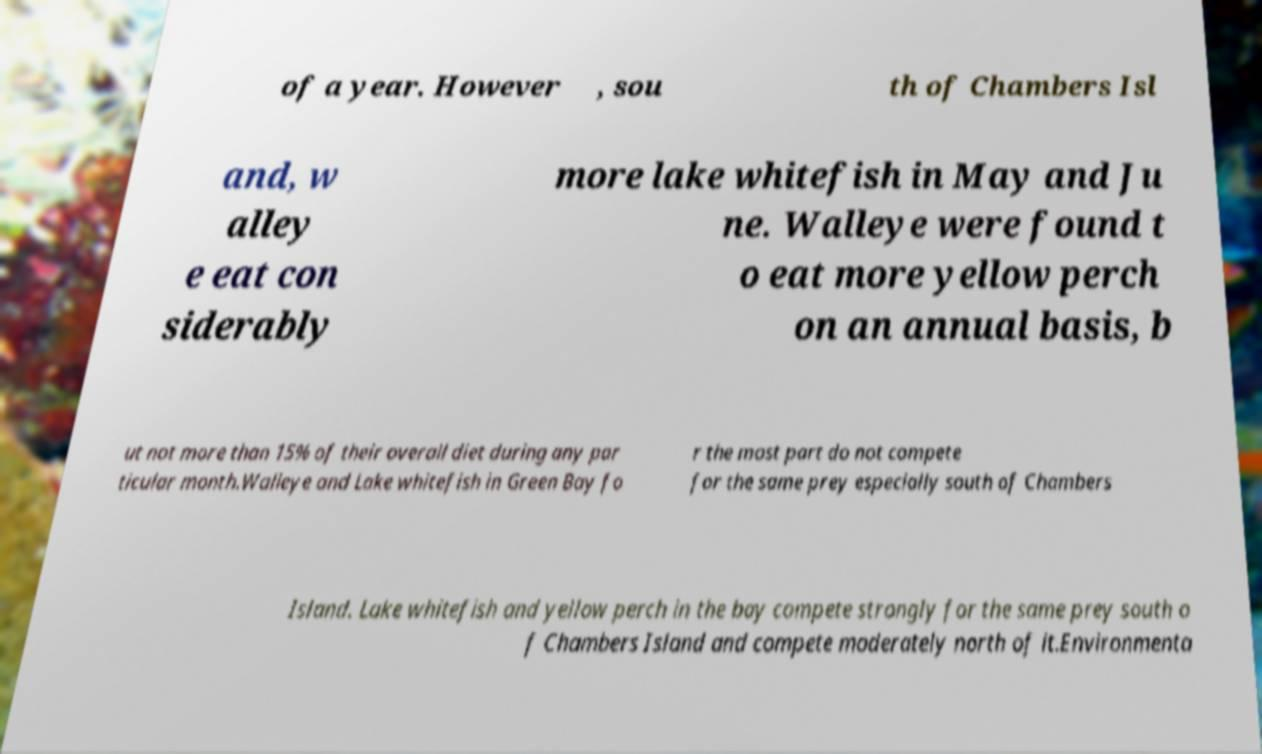I need the written content from this picture converted into text. Can you do that? of a year. However , sou th of Chambers Isl and, w alley e eat con siderably more lake whitefish in May and Ju ne. Walleye were found t o eat more yellow perch on an annual basis, b ut not more than 15% of their overall diet during any par ticular month.Walleye and Lake whitefish in Green Bay fo r the most part do not compete for the same prey especially south of Chambers Island. Lake whitefish and yellow perch in the bay compete strongly for the same prey south o f Chambers Island and compete moderately north of it.Environmenta 